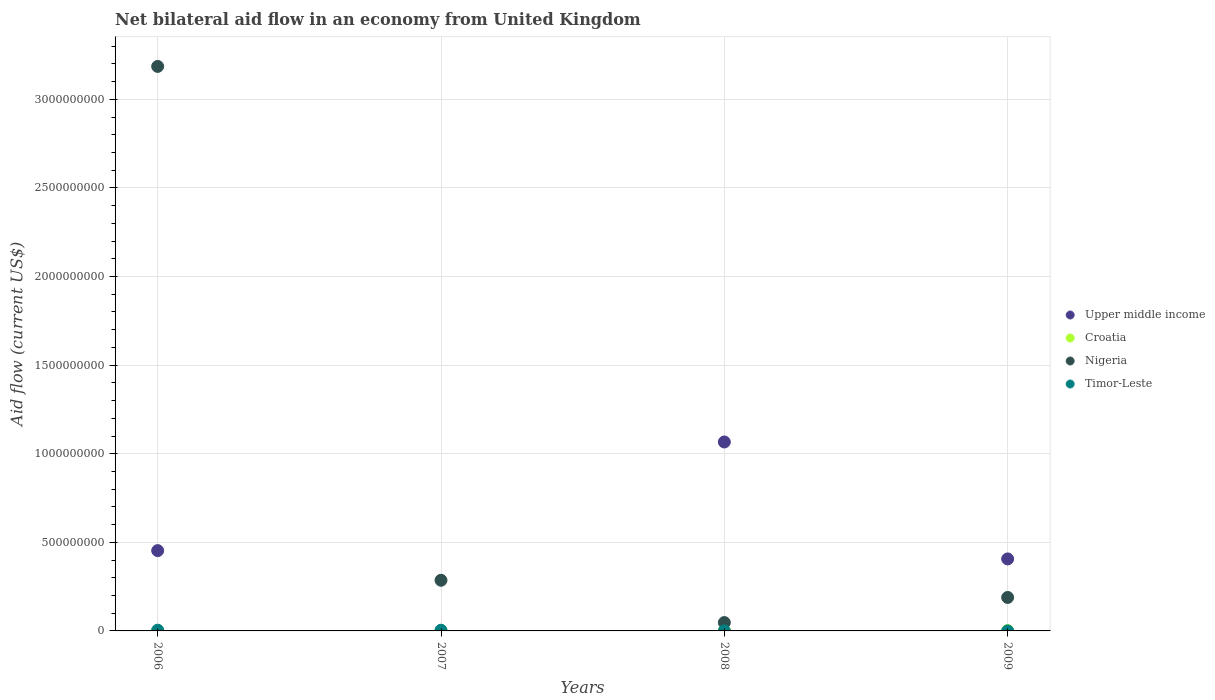How many different coloured dotlines are there?
Your answer should be very brief. 4. What is the net bilateral aid flow in Croatia in 2007?
Your response must be concise. 1.05e+06. Across all years, what is the maximum net bilateral aid flow in Timor-Leste?
Make the answer very short. 4.21e+06. Across all years, what is the minimum net bilateral aid flow in Nigeria?
Your answer should be compact. 4.72e+07. In which year was the net bilateral aid flow in Upper middle income maximum?
Make the answer very short. 2008. What is the total net bilateral aid flow in Timor-Leste in the graph?
Keep it short and to the point. 8.55e+06. What is the difference between the net bilateral aid flow in Croatia in 2008 and that in 2009?
Your response must be concise. -4.60e+05. What is the difference between the net bilateral aid flow in Croatia in 2009 and the net bilateral aid flow in Nigeria in 2007?
Your answer should be compact. -2.84e+08. What is the average net bilateral aid flow in Croatia per year?
Keep it short and to the point. 1.16e+06. In the year 2006, what is the difference between the net bilateral aid flow in Timor-Leste and net bilateral aid flow in Nigeria?
Your response must be concise. -3.18e+09. In how many years, is the net bilateral aid flow in Upper middle income greater than 800000000 US$?
Offer a terse response. 1. What is the ratio of the net bilateral aid flow in Nigeria in 2006 to that in 2008?
Your response must be concise. 67.48. Is the net bilateral aid flow in Upper middle income in 2008 less than that in 2009?
Provide a short and direct response. No. What is the difference between the highest and the second highest net bilateral aid flow in Timor-Leste?
Your answer should be very brief. 2.10e+05. What is the difference between the highest and the lowest net bilateral aid flow in Upper middle income?
Your answer should be compact. 1.07e+09. In how many years, is the net bilateral aid flow in Croatia greater than the average net bilateral aid flow in Croatia taken over all years?
Offer a very short reply. 2. Is the sum of the net bilateral aid flow in Nigeria in 2006 and 2009 greater than the maximum net bilateral aid flow in Croatia across all years?
Offer a terse response. Yes. Is it the case that in every year, the sum of the net bilateral aid flow in Nigeria and net bilateral aid flow in Croatia  is greater than the net bilateral aid flow in Timor-Leste?
Give a very brief answer. Yes. Does the net bilateral aid flow in Upper middle income monotonically increase over the years?
Provide a succinct answer. No. Is the net bilateral aid flow in Croatia strictly less than the net bilateral aid flow in Upper middle income over the years?
Offer a terse response. No. How many dotlines are there?
Your answer should be very brief. 4. What is the difference between two consecutive major ticks on the Y-axis?
Give a very brief answer. 5.00e+08. Does the graph contain any zero values?
Offer a terse response. Yes. What is the title of the graph?
Your answer should be very brief. Net bilateral aid flow in an economy from United Kingdom. What is the label or title of the Y-axis?
Offer a very short reply. Aid flow (current US$). What is the Aid flow (current US$) in Upper middle income in 2006?
Your answer should be compact. 4.53e+08. What is the Aid flow (current US$) in Nigeria in 2006?
Provide a succinct answer. 3.19e+09. What is the Aid flow (current US$) of Timor-Leste in 2006?
Ensure brevity in your answer.  4.21e+06. What is the Aid flow (current US$) of Croatia in 2007?
Give a very brief answer. 1.05e+06. What is the Aid flow (current US$) of Nigeria in 2007?
Provide a succinct answer. 2.86e+08. What is the Aid flow (current US$) of Upper middle income in 2008?
Keep it short and to the point. 1.07e+09. What is the Aid flow (current US$) of Croatia in 2008?
Ensure brevity in your answer.  1.41e+06. What is the Aid flow (current US$) in Nigeria in 2008?
Your response must be concise. 4.72e+07. What is the Aid flow (current US$) of Timor-Leste in 2008?
Give a very brief answer. 2.30e+05. What is the Aid flow (current US$) in Upper middle income in 2009?
Provide a succinct answer. 4.06e+08. What is the Aid flow (current US$) in Croatia in 2009?
Ensure brevity in your answer.  1.87e+06. What is the Aid flow (current US$) in Nigeria in 2009?
Provide a short and direct response. 1.89e+08. Across all years, what is the maximum Aid flow (current US$) of Upper middle income?
Offer a very short reply. 1.07e+09. Across all years, what is the maximum Aid flow (current US$) in Croatia?
Offer a terse response. 1.87e+06. Across all years, what is the maximum Aid flow (current US$) in Nigeria?
Provide a short and direct response. 3.19e+09. Across all years, what is the maximum Aid flow (current US$) in Timor-Leste?
Your response must be concise. 4.21e+06. Across all years, what is the minimum Aid flow (current US$) of Upper middle income?
Your response must be concise. 0. Across all years, what is the minimum Aid flow (current US$) in Croatia?
Provide a short and direct response. 3.10e+05. Across all years, what is the minimum Aid flow (current US$) of Nigeria?
Your answer should be compact. 4.72e+07. Across all years, what is the minimum Aid flow (current US$) in Timor-Leste?
Your response must be concise. 1.10e+05. What is the total Aid flow (current US$) of Upper middle income in the graph?
Provide a succinct answer. 1.93e+09. What is the total Aid flow (current US$) in Croatia in the graph?
Provide a short and direct response. 4.64e+06. What is the total Aid flow (current US$) in Nigeria in the graph?
Provide a succinct answer. 3.71e+09. What is the total Aid flow (current US$) in Timor-Leste in the graph?
Offer a terse response. 8.55e+06. What is the difference between the Aid flow (current US$) in Croatia in 2006 and that in 2007?
Provide a short and direct response. -7.40e+05. What is the difference between the Aid flow (current US$) of Nigeria in 2006 and that in 2007?
Your answer should be compact. 2.90e+09. What is the difference between the Aid flow (current US$) in Timor-Leste in 2006 and that in 2007?
Provide a short and direct response. 2.10e+05. What is the difference between the Aid flow (current US$) in Upper middle income in 2006 and that in 2008?
Give a very brief answer. -6.13e+08. What is the difference between the Aid flow (current US$) in Croatia in 2006 and that in 2008?
Offer a terse response. -1.10e+06. What is the difference between the Aid flow (current US$) in Nigeria in 2006 and that in 2008?
Make the answer very short. 3.14e+09. What is the difference between the Aid flow (current US$) of Timor-Leste in 2006 and that in 2008?
Make the answer very short. 3.98e+06. What is the difference between the Aid flow (current US$) of Upper middle income in 2006 and that in 2009?
Provide a succinct answer. 4.69e+07. What is the difference between the Aid flow (current US$) of Croatia in 2006 and that in 2009?
Offer a very short reply. -1.56e+06. What is the difference between the Aid flow (current US$) in Nigeria in 2006 and that in 2009?
Give a very brief answer. 3.00e+09. What is the difference between the Aid flow (current US$) of Timor-Leste in 2006 and that in 2009?
Provide a short and direct response. 4.10e+06. What is the difference between the Aid flow (current US$) of Croatia in 2007 and that in 2008?
Your answer should be compact. -3.60e+05. What is the difference between the Aid flow (current US$) of Nigeria in 2007 and that in 2008?
Provide a short and direct response. 2.39e+08. What is the difference between the Aid flow (current US$) of Timor-Leste in 2007 and that in 2008?
Ensure brevity in your answer.  3.77e+06. What is the difference between the Aid flow (current US$) in Croatia in 2007 and that in 2009?
Offer a very short reply. -8.20e+05. What is the difference between the Aid flow (current US$) in Nigeria in 2007 and that in 2009?
Offer a terse response. 9.71e+07. What is the difference between the Aid flow (current US$) of Timor-Leste in 2007 and that in 2009?
Provide a succinct answer. 3.89e+06. What is the difference between the Aid flow (current US$) of Upper middle income in 2008 and that in 2009?
Give a very brief answer. 6.60e+08. What is the difference between the Aid flow (current US$) of Croatia in 2008 and that in 2009?
Offer a very short reply. -4.60e+05. What is the difference between the Aid flow (current US$) of Nigeria in 2008 and that in 2009?
Your response must be concise. -1.42e+08. What is the difference between the Aid flow (current US$) of Upper middle income in 2006 and the Aid flow (current US$) of Croatia in 2007?
Provide a succinct answer. 4.52e+08. What is the difference between the Aid flow (current US$) of Upper middle income in 2006 and the Aid flow (current US$) of Nigeria in 2007?
Ensure brevity in your answer.  1.67e+08. What is the difference between the Aid flow (current US$) of Upper middle income in 2006 and the Aid flow (current US$) of Timor-Leste in 2007?
Your answer should be compact. 4.49e+08. What is the difference between the Aid flow (current US$) of Croatia in 2006 and the Aid flow (current US$) of Nigeria in 2007?
Ensure brevity in your answer.  -2.86e+08. What is the difference between the Aid flow (current US$) of Croatia in 2006 and the Aid flow (current US$) of Timor-Leste in 2007?
Provide a short and direct response. -3.69e+06. What is the difference between the Aid flow (current US$) in Nigeria in 2006 and the Aid flow (current US$) in Timor-Leste in 2007?
Provide a succinct answer. 3.18e+09. What is the difference between the Aid flow (current US$) in Upper middle income in 2006 and the Aid flow (current US$) in Croatia in 2008?
Your response must be concise. 4.52e+08. What is the difference between the Aid flow (current US$) in Upper middle income in 2006 and the Aid flow (current US$) in Nigeria in 2008?
Your response must be concise. 4.06e+08. What is the difference between the Aid flow (current US$) of Upper middle income in 2006 and the Aid flow (current US$) of Timor-Leste in 2008?
Your answer should be very brief. 4.53e+08. What is the difference between the Aid flow (current US$) of Croatia in 2006 and the Aid flow (current US$) of Nigeria in 2008?
Provide a short and direct response. -4.69e+07. What is the difference between the Aid flow (current US$) in Nigeria in 2006 and the Aid flow (current US$) in Timor-Leste in 2008?
Make the answer very short. 3.19e+09. What is the difference between the Aid flow (current US$) of Upper middle income in 2006 and the Aid flow (current US$) of Croatia in 2009?
Make the answer very short. 4.51e+08. What is the difference between the Aid flow (current US$) in Upper middle income in 2006 and the Aid flow (current US$) in Nigeria in 2009?
Keep it short and to the point. 2.64e+08. What is the difference between the Aid flow (current US$) in Upper middle income in 2006 and the Aid flow (current US$) in Timor-Leste in 2009?
Offer a terse response. 4.53e+08. What is the difference between the Aid flow (current US$) in Croatia in 2006 and the Aid flow (current US$) in Nigeria in 2009?
Make the answer very short. -1.89e+08. What is the difference between the Aid flow (current US$) in Croatia in 2006 and the Aid flow (current US$) in Timor-Leste in 2009?
Keep it short and to the point. 2.00e+05. What is the difference between the Aid flow (current US$) of Nigeria in 2006 and the Aid flow (current US$) of Timor-Leste in 2009?
Make the answer very short. 3.19e+09. What is the difference between the Aid flow (current US$) of Croatia in 2007 and the Aid flow (current US$) of Nigeria in 2008?
Ensure brevity in your answer.  -4.62e+07. What is the difference between the Aid flow (current US$) of Croatia in 2007 and the Aid flow (current US$) of Timor-Leste in 2008?
Provide a succinct answer. 8.20e+05. What is the difference between the Aid flow (current US$) of Nigeria in 2007 and the Aid flow (current US$) of Timor-Leste in 2008?
Provide a succinct answer. 2.86e+08. What is the difference between the Aid flow (current US$) of Croatia in 2007 and the Aid flow (current US$) of Nigeria in 2009?
Offer a terse response. -1.88e+08. What is the difference between the Aid flow (current US$) in Croatia in 2007 and the Aid flow (current US$) in Timor-Leste in 2009?
Ensure brevity in your answer.  9.40e+05. What is the difference between the Aid flow (current US$) of Nigeria in 2007 and the Aid flow (current US$) of Timor-Leste in 2009?
Provide a short and direct response. 2.86e+08. What is the difference between the Aid flow (current US$) of Upper middle income in 2008 and the Aid flow (current US$) of Croatia in 2009?
Your response must be concise. 1.06e+09. What is the difference between the Aid flow (current US$) in Upper middle income in 2008 and the Aid flow (current US$) in Nigeria in 2009?
Give a very brief answer. 8.77e+08. What is the difference between the Aid flow (current US$) in Upper middle income in 2008 and the Aid flow (current US$) in Timor-Leste in 2009?
Ensure brevity in your answer.  1.07e+09. What is the difference between the Aid flow (current US$) in Croatia in 2008 and the Aid flow (current US$) in Nigeria in 2009?
Make the answer very short. -1.87e+08. What is the difference between the Aid flow (current US$) in Croatia in 2008 and the Aid flow (current US$) in Timor-Leste in 2009?
Keep it short and to the point. 1.30e+06. What is the difference between the Aid flow (current US$) of Nigeria in 2008 and the Aid flow (current US$) of Timor-Leste in 2009?
Give a very brief answer. 4.71e+07. What is the average Aid flow (current US$) of Upper middle income per year?
Your response must be concise. 4.81e+08. What is the average Aid flow (current US$) of Croatia per year?
Your response must be concise. 1.16e+06. What is the average Aid flow (current US$) of Nigeria per year?
Make the answer very short. 9.27e+08. What is the average Aid flow (current US$) of Timor-Leste per year?
Keep it short and to the point. 2.14e+06. In the year 2006, what is the difference between the Aid flow (current US$) of Upper middle income and Aid flow (current US$) of Croatia?
Offer a terse response. 4.53e+08. In the year 2006, what is the difference between the Aid flow (current US$) of Upper middle income and Aid flow (current US$) of Nigeria?
Make the answer very short. -2.73e+09. In the year 2006, what is the difference between the Aid flow (current US$) in Upper middle income and Aid flow (current US$) in Timor-Leste?
Your answer should be compact. 4.49e+08. In the year 2006, what is the difference between the Aid flow (current US$) in Croatia and Aid flow (current US$) in Nigeria?
Provide a short and direct response. -3.19e+09. In the year 2006, what is the difference between the Aid flow (current US$) in Croatia and Aid flow (current US$) in Timor-Leste?
Provide a succinct answer. -3.90e+06. In the year 2006, what is the difference between the Aid flow (current US$) in Nigeria and Aid flow (current US$) in Timor-Leste?
Offer a terse response. 3.18e+09. In the year 2007, what is the difference between the Aid flow (current US$) in Croatia and Aid flow (current US$) in Nigeria?
Provide a succinct answer. -2.85e+08. In the year 2007, what is the difference between the Aid flow (current US$) in Croatia and Aid flow (current US$) in Timor-Leste?
Ensure brevity in your answer.  -2.95e+06. In the year 2007, what is the difference between the Aid flow (current US$) of Nigeria and Aid flow (current US$) of Timor-Leste?
Provide a short and direct response. 2.82e+08. In the year 2008, what is the difference between the Aid flow (current US$) of Upper middle income and Aid flow (current US$) of Croatia?
Offer a terse response. 1.06e+09. In the year 2008, what is the difference between the Aid flow (current US$) in Upper middle income and Aid flow (current US$) in Nigeria?
Offer a very short reply. 1.02e+09. In the year 2008, what is the difference between the Aid flow (current US$) of Upper middle income and Aid flow (current US$) of Timor-Leste?
Your response must be concise. 1.07e+09. In the year 2008, what is the difference between the Aid flow (current US$) in Croatia and Aid flow (current US$) in Nigeria?
Ensure brevity in your answer.  -4.58e+07. In the year 2008, what is the difference between the Aid flow (current US$) in Croatia and Aid flow (current US$) in Timor-Leste?
Give a very brief answer. 1.18e+06. In the year 2008, what is the difference between the Aid flow (current US$) in Nigeria and Aid flow (current US$) in Timor-Leste?
Your answer should be very brief. 4.70e+07. In the year 2009, what is the difference between the Aid flow (current US$) of Upper middle income and Aid flow (current US$) of Croatia?
Provide a short and direct response. 4.04e+08. In the year 2009, what is the difference between the Aid flow (current US$) in Upper middle income and Aid flow (current US$) in Nigeria?
Ensure brevity in your answer.  2.17e+08. In the year 2009, what is the difference between the Aid flow (current US$) in Upper middle income and Aid flow (current US$) in Timor-Leste?
Your response must be concise. 4.06e+08. In the year 2009, what is the difference between the Aid flow (current US$) of Croatia and Aid flow (current US$) of Nigeria?
Your answer should be very brief. -1.87e+08. In the year 2009, what is the difference between the Aid flow (current US$) of Croatia and Aid flow (current US$) of Timor-Leste?
Offer a very short reply. 1.76e+06. In the year 2009, what is the difference between the Aid flow (current US$) in Nigeria and Aid flow (current US$) in Timor-Leste?
Provide a short and direct response. 1.89e+08. What is the ratio of the Aid flow (current US$) in Croatia in 2006 to that in 2007?
Keep it short and to the point. 0.3. What is the ratio of the Aid flow (current US$) of Nigeria in 2006 to that in 2007?
Keep it short and to the point. 11.14. What is the ratio of the Aid flow (current US$) of Timor-Leste in 2006 to that in 2007?
Provide a short and direct response. 1.05. What is the ratio of the Aid flow (current US$) in Upper middle income in 2006 to that in 2008?
Provide a short and direct response. 0.42. What is the ratio of the Aid flow (current US$) of Croatia in 2006 to that in 2008?
Your answer should be compact. 0.22. What is the ratio of the Aid flow (current US$) of Nigeria in 2006 to that in 2008?
Your response must be concise. 67.48. What is the ratio of the Aid flow (current US$) of Timor-Leste in 2006 to that in 2008?
Keep it short and to the point. 18.3. What is the ratio of the Aid flow (current US$) of Upper middle income in 2006 to that in 2009?
Your response must be concise. 1.12. What is the ratio of the Aid flow (current US$) in Croatia in 2006 to that in 2009?
Make the answer very short. 0.17. What is the ratio of the Aid flow (current US$) of Nigeria in 2006 to that in 2009?
Your answer should be compact. 16.87. What is the ratio of the Aid flow (current US$) of Timor-Leste in 2006 to that in 2009?
Your response must be concise. 38.27. What is the ratio of the Aid flow (current US$) in Croatia in 2007 to that in 2008?
Your response must be concise. 0.74. What is the ratio of the Aid flow (current US$) of Nigeria in 2007 to that in 2008?
Provide a short and direct response. 6.06. What is the ratio of the Aid flow (current US$) of Timor-Leste in 2007 to that in 2008?
Offer a very short reply. 17.39. What is the ratio of the Aid flow (current US$) of Croatia in 2007 to that in 2009?
Offer a terse response. 0.56. What is the ratio of the Aid flow (current US$) in Nigeria in 2007 to that in 2009?
Ensure brevity in your answer.  1.51. What is the ratio of the Aid flow (current US$) of Timor-Leste in 2007 to that in 2009?
Ensure brevity in your answer.  36.36. What is the ratio of the Aid flow (current US$) in Upper middle income in 2008 to that in 2009?
Give a very brief answer. 2.62. What is the ratio of the Aid flow (current US$) in Croatia in 2008 to that in 2009?
Give a very brief answer. 0.75. What is the ratio of the Aid flow (current US$) of Nigeria in 2008 to that in 2009?
Provide a succinct answer. 0.25. What is the ratio of the Aid flow (current US$) in Timor-Leste in 2008 to that in 2009?
Ensure brevity in your answer.  2.09. What is the difference between the highest and the second highest Aid flow (current US$) in Upper middle income?
Provide a short and direct response. 6.13e+08. What is the difference between the highest and the second highest Aid flow (current US$) in Croatia?
Offer a terse response. 4.60e+05. What is the difference between the highest and the second highest Aid flow (current US$) of Nigeria?
Give a very brief answer. 2.90e+09. What is the difference between the highest and the lowest Aid flow (current US$) of Upper middle income?
Your answer should be compact. 1.07e+09. What is the difference between the highest and the lowest Aid flow (current US$) of Croatia?
Keep it short and to the point. 1.56e+06. What is the difference between the highest and the lowest Aid flow (current US$) of Nigeria?
Your answer should be compact. 3.14e+09. What is the difference between the highest and the lowest Aid flow (current US$) in Timor-Leste?
Provide a short and direct response. 4.10e+06. 